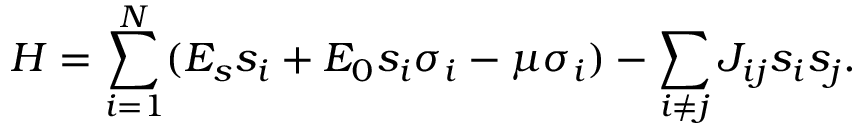<formula> <loc_0><loc_0><loc_500><loc_500>H = \sum _ { i = 1 } ^ { N } ( E _ { s } s _ { i } + E _ { 0 } s _ { i } \sigma _ { i } - \mu \sigma _ { i } ) - \sum _ { i \neq j } J _ { i j } s _ { i } s _ { j } .</formula> 